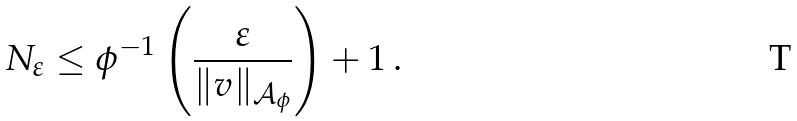<formula> <loc_0><loc_0><loc_500><loc_500>N _ { \varepsilon } \leq \phi ^ { - 1 } \left ( \frac { \varepsilon } { \| v \| _ { { \mathcal { A } } _ { \phi } } } \right ) + 1 \, .</formula> 